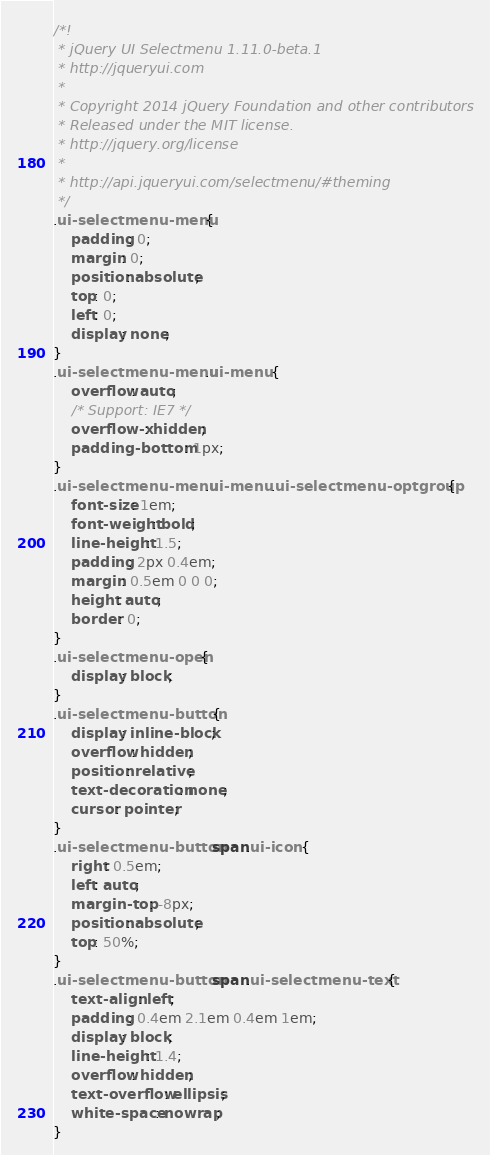<code> <loc_0><loc_0><loc_500><loc_500><_CSS_>/*!
 * jQuery UI Selectmenu 1.11.0-beta.1
 * http://jqueryui.com
 *
 * Copyright 2014 jQuery Foundation and other contributors
 * Released under the MIT license.
 * http://jquery.org/license
 *
 * http://api.jqueryui.com/selectmenu/#theming
 */
.ui-selectmenu-menu {
	padding: 0;
	margin: 0;
	position: absolute;
	top: 0;
	left: 0;
	display: none;
}
.ui-selectmenu-menu .ui-menu {
	overflow: auto;
	/* Support: IE7 */
	overflow-x: hidden;
	padding-bottom: 1px;
}
.ui-selectmenu-menu .ui-menu .ui-selectmenu-optgroup {
	font-size: 1em;
	font-weight: bold;
	line-height: 1.5;
	padding: 2px 0.4em;
	margin: 0.5em 0 0 0;
	height: auto;
	border: 0;
}
.ui-selectmenu-open {
	display: block;
}
.ui-selectmenu-button {
	display: inline-block;
	overflow: hidden;
	position: relative;
	text-decoration: none;
	cursor: pointer;
}
.ui-selectmenu-button span.ui-icon {
	right: 0.5em;
	left: auto;
	margin-top: -8px;
	position: absolute;
	top: 50%;
}
.ui-selectmenu-button span.ui-selectmenu-text {
	text-align: left;
	padding: 0.4em 2.1em 0.4em 1em;
	display: block;
	line-height: 1.4;
	overflow: hidden;
	text-overflow: ellipsis;
	white-space: nowrap;
}
</code> 